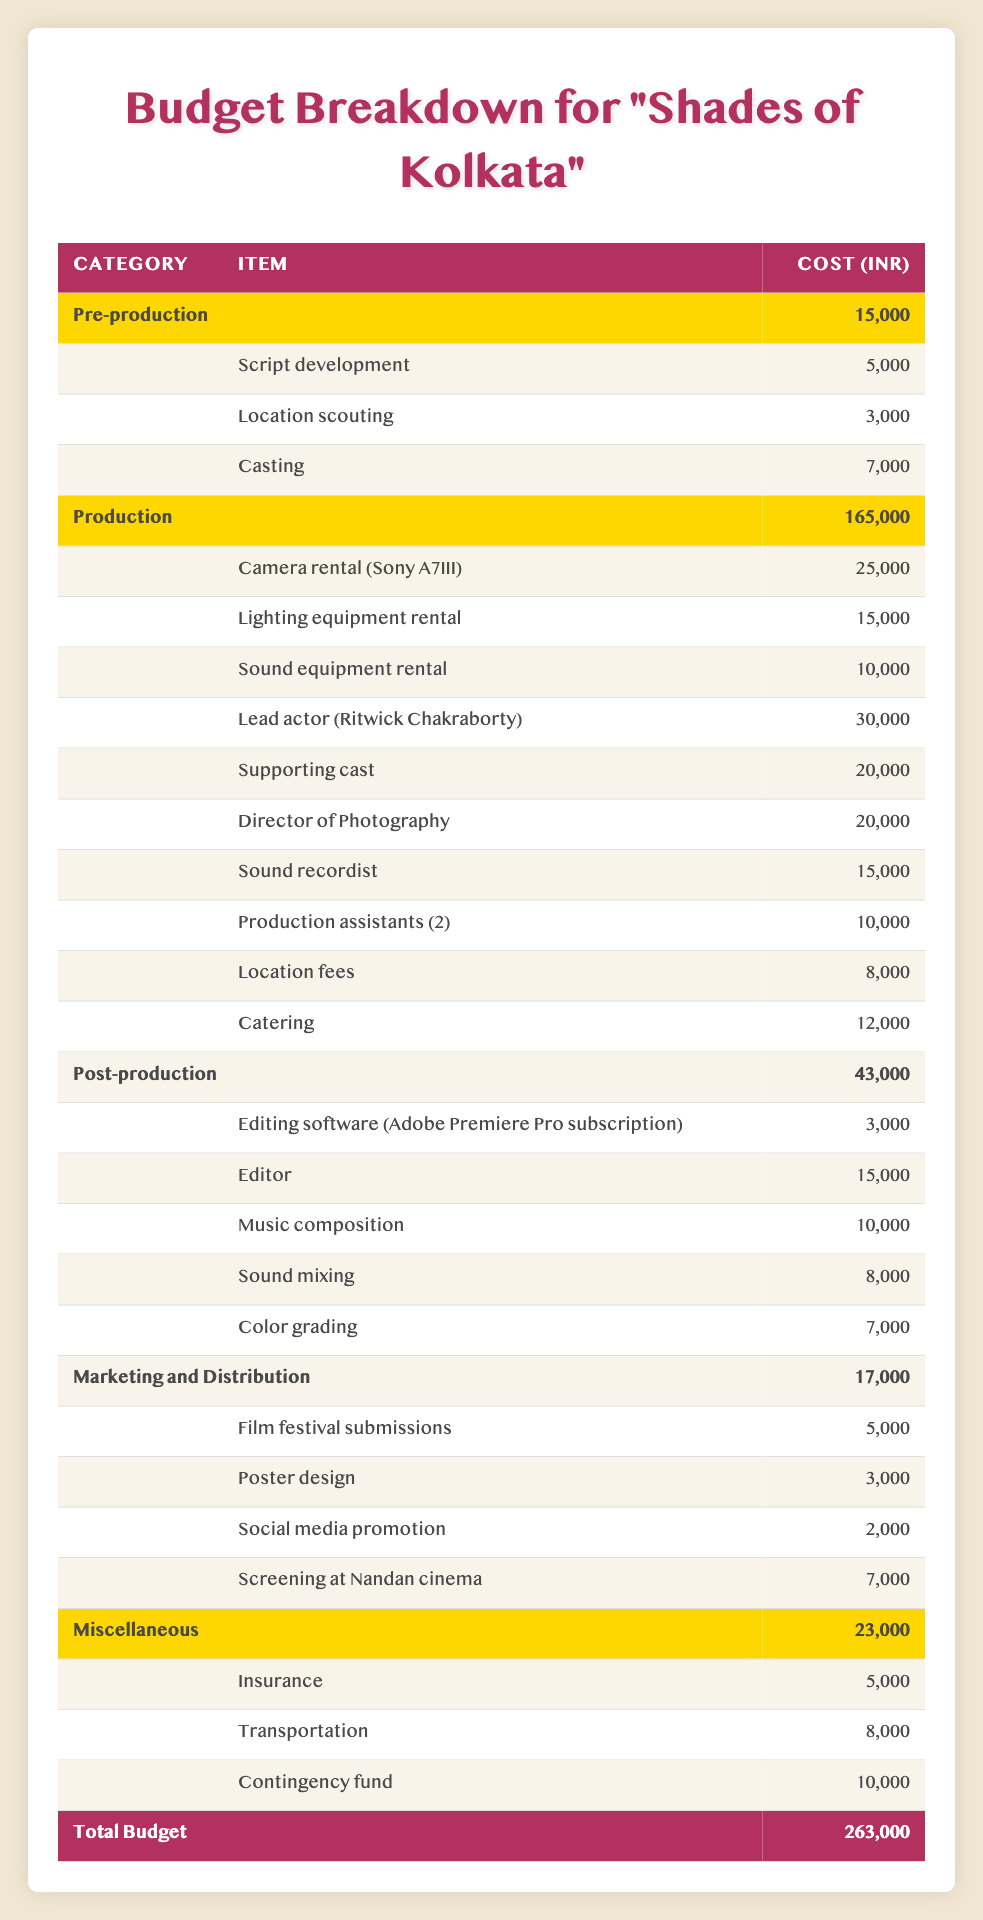What is the total budget for "Shades of Kolkata"? The total budget is listed in the table under the total budget section, which states that the total budget is 200000 INR.
Answer: 200000 INR How much is allocated for production? The total cost allocated for production can be found by looking at the production category, where the total is listed as 165000 INR.
Answer: 165000 INR Is the cost of the lead actor higher than that of the camera rental? The cost of the lead actor is listed as 30000 INR, and the cost of camera rental is 25000 INR. Since 30000 is greater than 25000, this statement is true.
Answer: Yes What is the combined cost of pre-production and post-production? To find the combined cost, add the pre-production total (15000 INR) and the post-production total (43000 INR). The sum is 15000 + 43000 = 58000 INR.
Answer: 58000 INR What is the average cost of items in the miscellaneous category? The miscellaneous category has three items: Insurance (5000), Transportation (8000), and Contingency fund (10000) with a total of 23000 INR. Divide the total by the number of items to get the average, which is 23000/3 = 7666.67 INR.
Answer: 7666.67 INR How much is spent on marketing compared to pre-production? The marketing costs total 17000 INR, while the pre-production costs total is 15000 INR. To see how much more is spent on marketing, subtract the pre-production amount from the marketing amount: 17000 - 15000 = 2000 INR. Marketing costs 2000 INR more than pre-production.
Answer: 2000 INR Is the total budget for post-production less than the total for marketing and distribution combined? The total for post-production is 43000 INR, and the total for marketing and distribution is 17000 INR. Combine these two amounts: 43000 + 17000 = 60000 INR. Since 60000 INR is greater than 43000 INR, the post-production budget is indeed less.
Answer: Yes What is the highest individual cost in the production category? Looking at the production category, we find the costs listed. The highest cost is for the lead actor at 30000 INR.
Answer: 30000 INR How much more is spent on the editor than on the editing software? The cost for editing software is 3000 INR, and the cost for the editor is 15000 INR. The difference is calculated as 15000 - 3000 = 12000 INR.
Answer: 12000 INR 